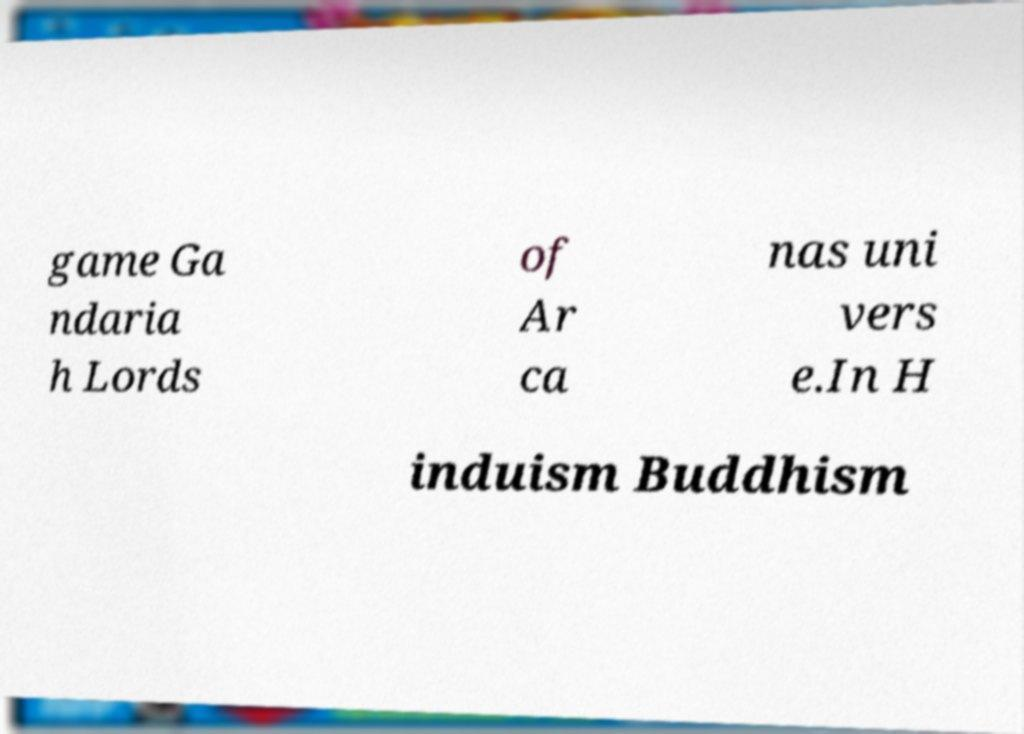Please identify and transcribe the text found in this image. game Ga ndaria h Lords of Ar ca nas uni vers e.In H induism Buddhism 